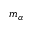<formula> <loc_0><loc_0><loc_500><loc_500>m _ { \alpha }</formula> 